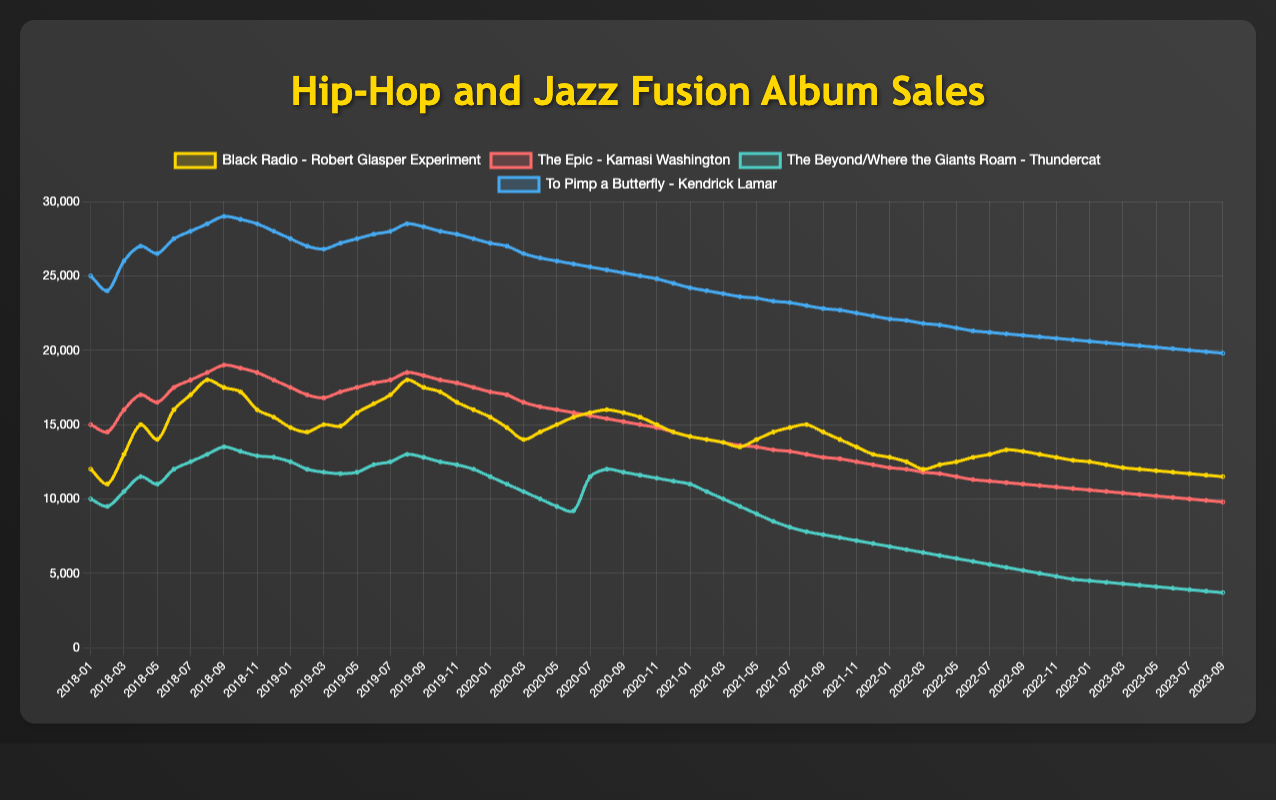What album had the highest peak monthly sales, and what was the sales figure? Look at the highest points on each line in the chart. "To Pimp a Butterfly" by Kendrick Lamar has the highest peak monthly sales, reaching 29,000 copies in September 2018.
Answer: To Pimp a Butterfly, 29,000 Between "The Epic" by Kamasi Washington and "The Beyond/Where the Giants Roam" by Thundercat, which one had higher sales in January 2020, and by how much? Check the sales data for both albums in January 2020. "The Epic" had 17,200 sales whereas "The Beyond/Where the Giants Roam" had 11,500 sales. The difference is 17,200 - 11,500 = 5,700.
Answer: The Epic, 5,700 Which album showed the most consistent sales trend without significant drops or peaks over the 5 years? Observe the lines that have the least fluctuation in sales. "To Pimp a Butterfly" by Kendrick Lamar shows a steady decline without notable peaks or drops.
Answer: To Pimp a Butterfly By how much did the sales of "Black Radio" by Robert Glasper Experiment decrease from January 2018 to September 2023? Check the sales figures for both months for "Black Radio." January 2018 had 12,000 sales and September 2023 had 11,500 sales. The decrease is 12,000 - 11,500 = 500.
Answer: 500 What's the total sales of "The Beyond/Where the Giants Roam" by Thundercat for the entire year of 2018? Sum the sales for each month of 2018 for "The Beyond/Where the Giants Roam." Adding up the sales: 10,000 + 9,500 + 10,500 + 11,500 + 11,000 + 12,000 + 12,500 + 13,000 + 13,500 + 13,200 + 12,900 + 12,800 = 142,400.
Answer: 142,400 In which year did "The Epic" by Kamasi Washington experience the sharpest decline in monthly sales? Look for the year with the steepest downward trend in the chart for "The Epic." The sharpest decline is seen in 2022 when sales drop significantly in almost every month.
Answer: 2022 Compare the sales trends of "Black Radio" and "The Epic" in 2020, which album had a more consistent sales decline through the months? Review the monthly sales for 2020 for both albums. "The Epic" shows a more consistent decline without major spikes, while "Black Radio" has a slight increase and decrease pattern.
Answer: The Epic Which album had a turning point where its sales went from increasing to decreasing in the middle of the 5-year period? Identify the point where a line changes direction from rising to falling. "Black Radio" peaks around mid-2019 and then starts a decline.
Answer: Black Radio By how much did the sales of "To Pimp a Butterfly" by Kendrick Lamar decrease from January 2022 to January 2023? Compare the sales figures for January 2022 and January 2023 for "To Pimp a Butterfly." January 2022 had 22,100 sales and January 2023 had 20,600 sales. The decrease is 22,100 - 20,600 = 1,500.
Answer: 1,500 What's the average monthly sales of "The Beyond/Where the Giants Roam" by Thundercat in 2023 so far? Calculate the average by summing the monthly sales data for "The Beyond/Where the Giants Roam" in 2023 up to September, then dividing by the number of months (9). The sum is 4,500 + 4,400 + 4,300 + 4,200 + 4,100 + 4,000 + 3,900 + 3,800 + 3,700 = 36,900. The average is 36,900 / 9 = 4,100.
Answer: 4,100 